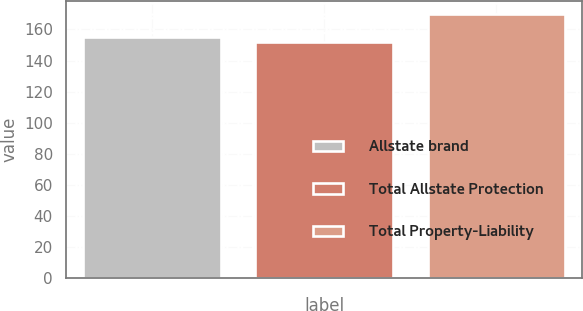Convert chart. <chart><loc_0><loc_0><loc_500><loc_500><bar_chart><fcel>Allstate brand<fcel>Total Allstate Protection<fcel>Total Property-Liability<nl><fcel>155<fcel>152<fcel>170<nl></chart> 